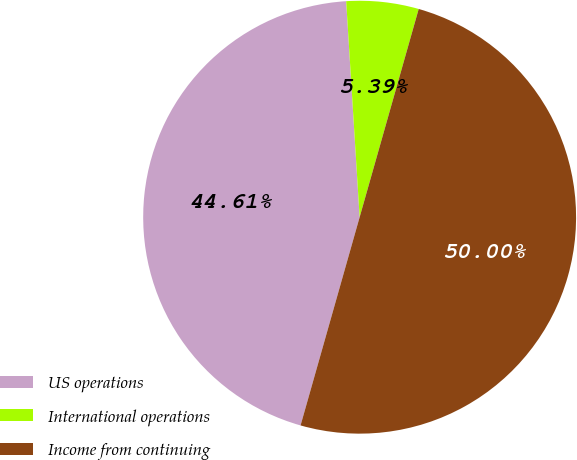<chart> <loc_0><loc_0><loc_500><loc_500><pie_chart><fcel>US operations<fcel>International operations<fcel>Income from continuing<nl><fcel>44.61%<fcel>5.39%<fcel>50.0%<nl></chart> 